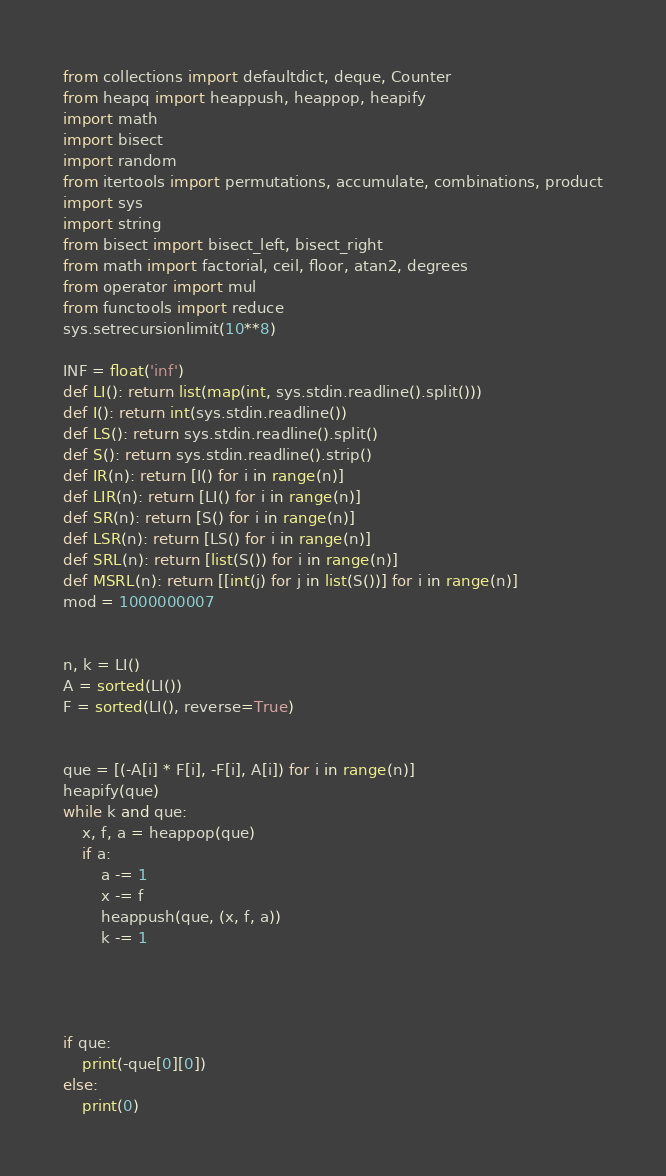<code> <loc_0><loc_0><loc_500><loc_500><_Python_>from collections import defaultdict, deque, Counter
from heapq import heappush, heappop, heapify
import math
import bisect
import random
from itertools import permutations, accumulate, combinations, product
import sys
import string
from bisect import bisect_left, bisect_right
from math import factorial, ceil, floor, atan2, degrees
from operator import mul
from functools import reduce
sys.setrecursionlimit(10**8)

INF = float('inf')
def LI(): return list(map(int, sys.stdin.readline().split()))
def I(): return int(sys.stdin.readline())
def LS(): return sys.stdin.readline().split()
def S(): return sys.stdin.readline().strip()
def IR(n): return [I() for i in range(n)]
def LIR(n): return [LI() for i in range(n)]
def SR(n): return [S() for i in range(n)]
def LSR(n): return [LS() for i in range(n)]
def SRL(n): return [list(S()) for i in range(n)]
def MSRL(n): return [[int(j) for j in list(S())] for i in range(n)]
mod = 1000000007


n, k = LI()
A = sorted(LI())
F = sorted(LI(), reverse=True)


que = [(-A[i] * F[i], -F[i], A[i]) for i in range(n)]
heapify(que)
while k and que:
    x, f, a = heappop(que)
    if a:
        a -= 1
        x -= f
        heappush(que, (x, f, a))
        k -= 1




if que:
    print(-que[0][0])
else:
    print(0)
</code> 